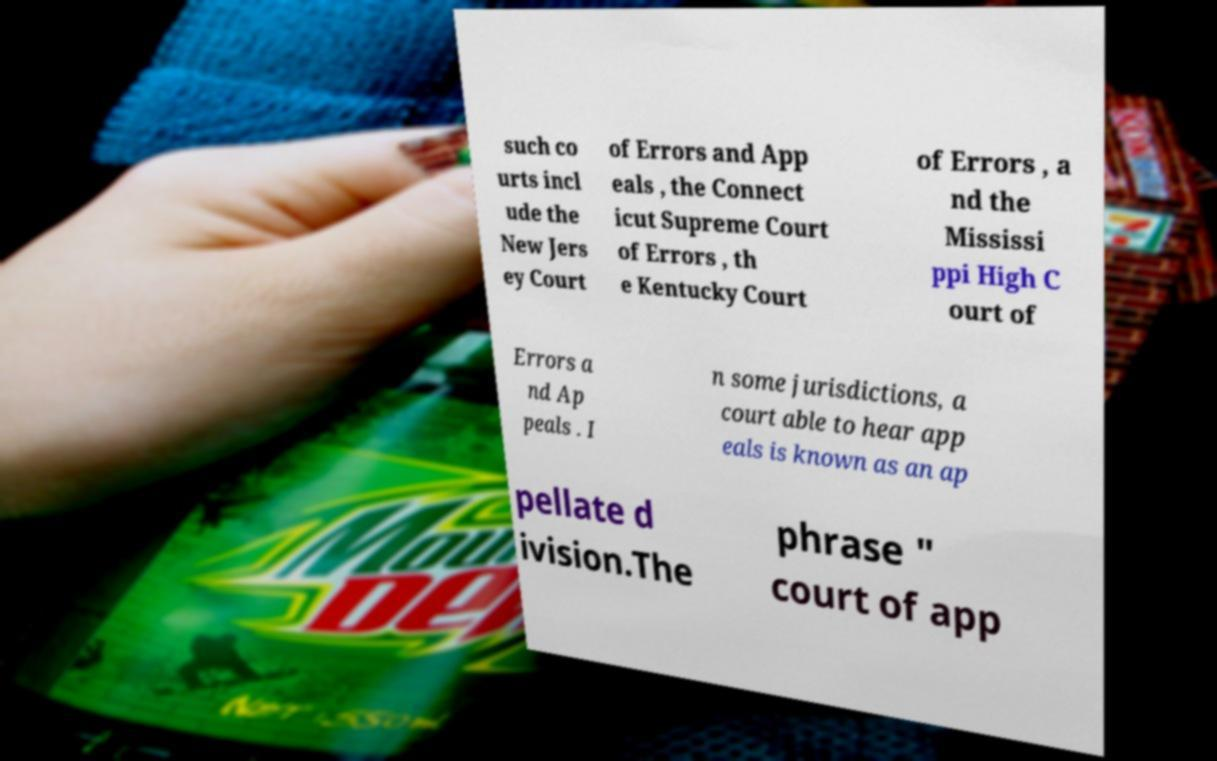Can you read and provide the text displayed in the image?This photo seems to have some interesting text. Can you extract and type it out for me? such co urts incl ude the New Jers ey Court of Errors and App eals , the Connect icut Supreme Court of Errors , th e Kentucky Court of Errors , a nd the Mississi ppi High C ourt of Errors a nd Ap peals . I n some jurisdictions, a court able to hear app eals is known as an ap pellate d ivision.The phrase " court of app 